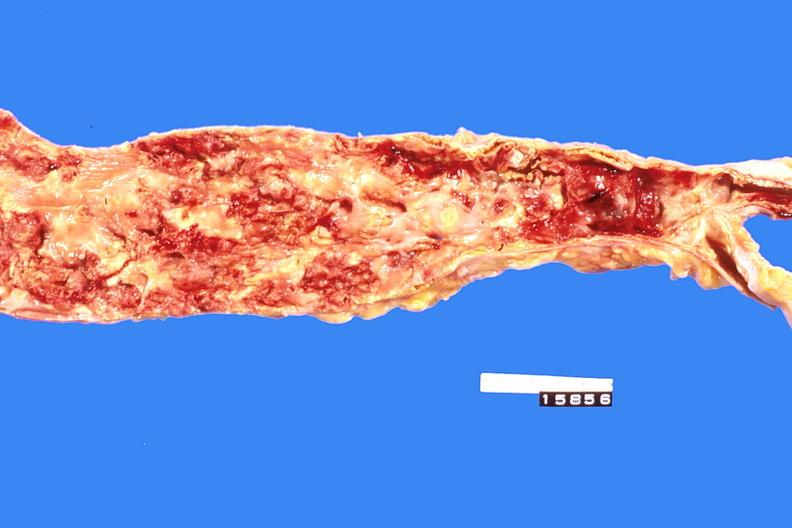what is present?
Answer the question using a single word or phrase. Cardiovascular 